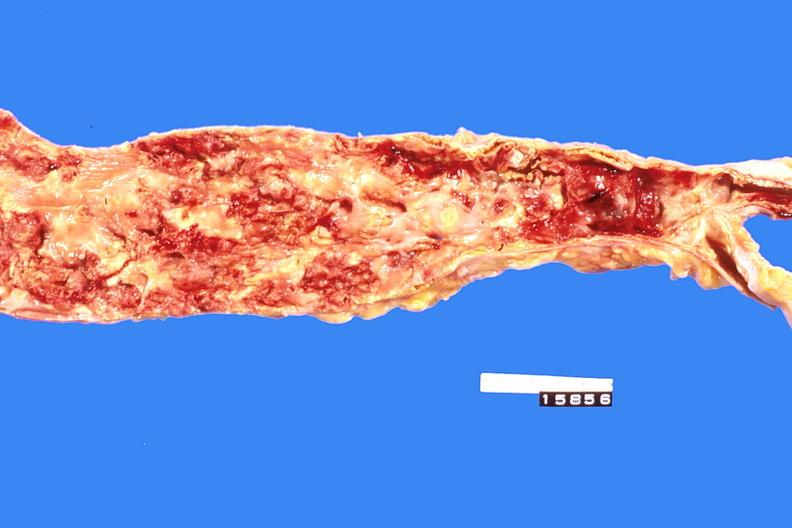what is present?
Answer the question using a single word or phrase. Cardiovascular 